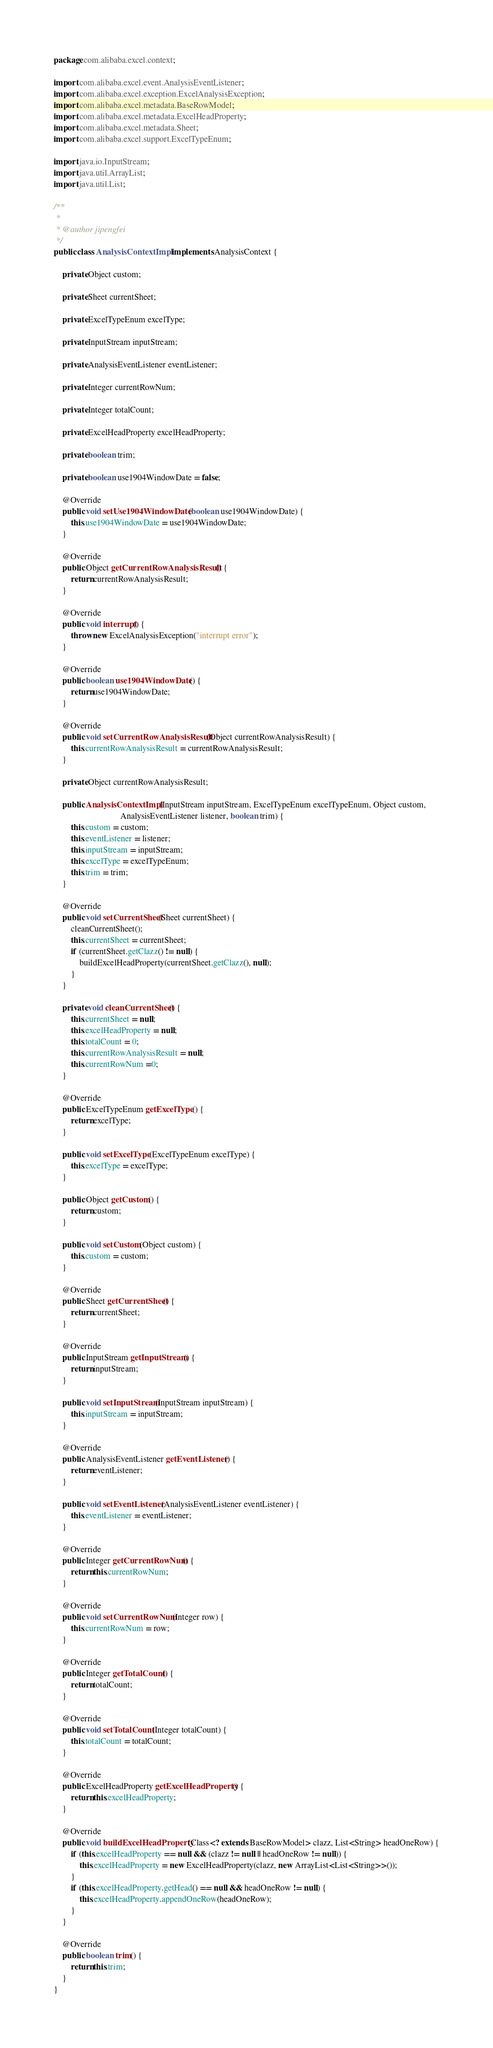<code> <loc_0><loc_0><loc_500><loc_500><_Java_>package com.alibaba.excel.context;

import com.alibaba.excel.event.AnalysisEventListener;
import com.alibaba.excel.exception.ExcelAnalysisException;
import com.alibaba.excel.metadata.BaseRowModel;
import com.alibaba.excel.metadata.ExcelHeadProperty;
import com.alibaba.excel.metadata.Sheet;
import com.alibaba.excel.support.ExcelTypeEnum;

import java.io.InputStream;
import java.util.ArrayList;
import java.util.List;

/**
 *
 * @author jipengfei
 */
public class AnalysisContextImpl implements AnalysisContext {

    private Object custom;

    private Sheet currentSheet;

    private ExcelTypeEnum excelType;

    private InputStream inputStream;

    private AnalysisEventListener eventListener;

    private Integer currentRowNum;

    private Integer totalCount;

    private ExcelHeadProperty excelHeadProperty;

    private boolean trim;

    private boolean use1904WindowDate = false;

    @Override
    public void setUse1904WindowDate(boolean use1904WindowDate) {
        this.use1904WindowDate = use1904WindowDate;
    }

    @Override
    public Object getCurrentRowAnalysisResult() {
        return currentRowAnalysisResult;
    }

    @Override
    public void interrupt() {
        throw new ExcelAnalysisException("interrupt error");
    }

    @Override
    public boolean use1904WindowDate() {
        return use1904WindowDate;
    }

    @Override
    public void setCurrentRowAnalysisResult(Object currentRowAnalysisResult) {
        this.currentRowAnalysisResult = currentRowAnalysisResult;
    }

    private Object currentRowAnalysisResult;

    public AnalysisContextImpl(InputStream inputStream, ExcelTypeEnum excelTypeEnum, Object custom,
                               AnalysisEventListener listener, boolean trim) {
        this.custom = custom;
        this.eventListener = listener;
        this.inputStream = inputStream;
        this.excelType = excelTypeEnum;
        this.trim = trim;
    }

    @Override
    public void setCurrentSheet(Sheet currentSheet) {
        cleanCurrentSheet();
        this.currentSheet = currentSheet;
        if (currentSheet.getClazz() != null) {
            buildExcelHeadProperty(currentSheet.getClazz(), null);
        }
    }

    private void cleanCurrentSheet() {
        this.currentSheet = null;
        this.excelHeadProperty = null;
        this.totalCount = 0;
        this.currentRowAnalysisResult = null;
        this.currentRowNum =0;
    }

    @Override
    public ExcelTypeEnum getExcelType() {
        return excelType;
    }

    public void setExcelType(ExcelTypeEnum excelType) {
        this.excelType = excelType;
    }

    public Object getCustom() {
        return custom;
    }

    public void setCustom(Object custom) {
        this.custom = custom;
    }

    @Override
    public Sheet getCurrentSheet() {
        return currentSheet;
    }

    @Override
    public InputStream getInputStream() {
        return inputStream;
    }

    public void setInputStream(InputStream inputStream) {
        this.inputStream = inputStream;
    }

    @Override
    public AnalysisEventListener getEventListener() {
        return eventListener;
    }

    public void setEventListener(AnalysisEventListener eventListener) {
        this.eventListener = eventListener;
    }

    @Override
    public Integer getCurrentRowNum() {
        return this.currentRowNum;
    }

    @Override
    public void setCurrentRowNum(Integer row) {
        this.currentRowNum = row;
    }

    @Override
    public Integer getTotalCount() {
        return totalCount;
    }

    @Override
    public void setTotalCount(Integer totalCount) {
        this.totalCount = totalCount;
    }

    @Override
    public ExcelHeadProperty getExcelHeadProperty() {
        return this.excelHeadProperty;
    }

    @Override
    public void buildExcelHeadProperty(Class<? extends BaseRowModel> clazz, List<String> headOneRow) {
        if (this.excelHeadProperty == null && (clazz != null || headOneRow != null)) {
            this.excelHeadProperty = new ExcelHeadProperty(clazz, new ArrayList<List<String>>());
        }
        if (this.excelHeadProperty.getHead() == null && headOneRow != null) {
            this.excelHeadProperty.appendOneRow(headOneRow);
        }
    }

    @Override
    public boolean trim() {
        return this.trim;
    }
}
</code> 